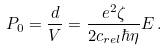<formula> <loc_0><loc_0><loc_500><loc_500>P _ { 0 } = \frac { d } { V } = \frac { e ^ { 2 } \zeta } { 2 c _ { r e l } \hbar { \eta } } E \, .</formula> 